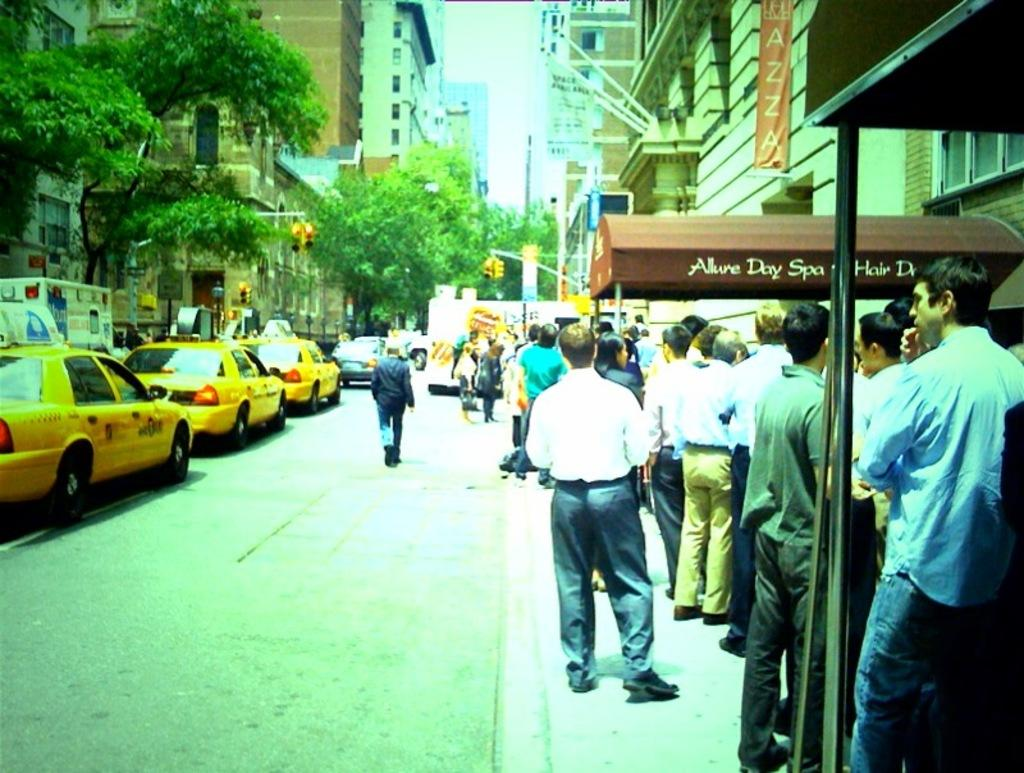<image>
Provide a brief description of the given image. Line forming of customers at Allure Day Spa on the canopy. 